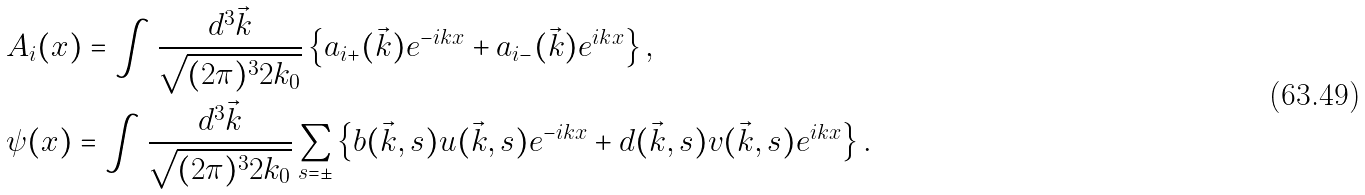Convert formula to latex. <formula><loc_0><loc_0><loc_500><loc_500>& A _ { i } ( x ) = \int \frac { d ^ { 3 } \vec { k } } { \sqrt { ( 2 \pi ) ^ { 3 } 2 k _ { 0 } } } \left \{ a _ { i + } ( \vec { k } ) e ^ { - i k x } + a _ { i - } ( \vec { k } ) e ^ { i k x } \right \} , \\ & \psi ( x ) = \int \frac { d ^ { 3 } \vec { k } } { \sqrt { ( 2 \pi ) ^ { 3 } 2 k _ { 0 } } } \sum _ { s = \pm } \left \{ b ( \vec { k } , s ) u ( \vec { k } , s ) e ^ { - i k x } + d ( \vec { k } , s ) v ( \vec { k } , s ) e ^ { i k x } \right \} .</formula> 